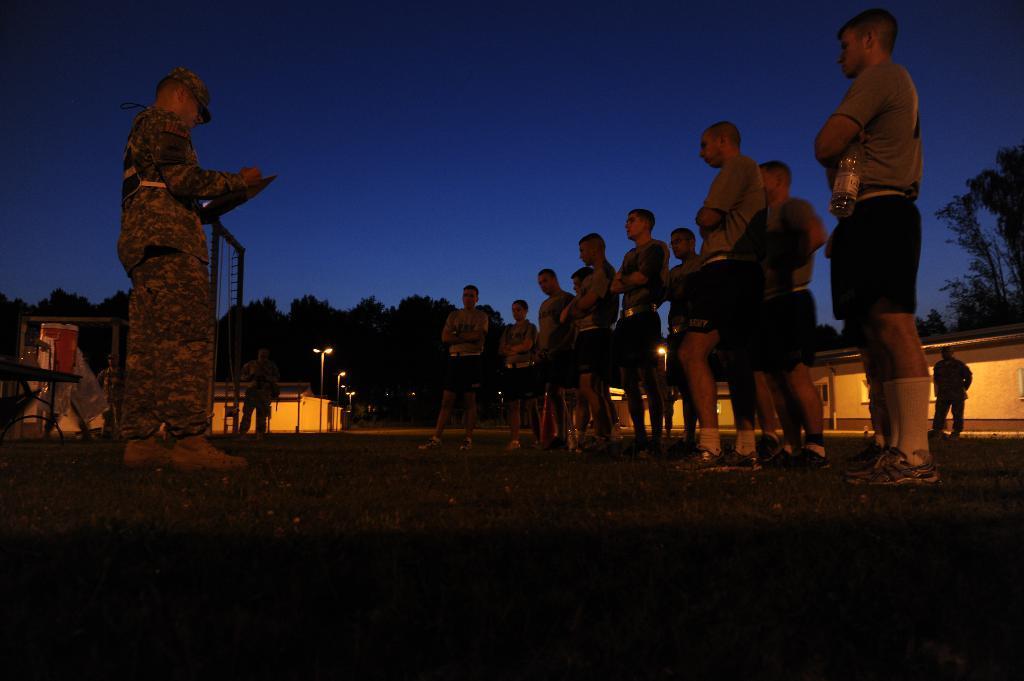Please provide a concise description of this image. Here in this image on the left, there is a man standing and holding a book in his hand. On the right, there are men standing. In the background, we can see persons, street lights, tables, rooms, trees and the sky. 